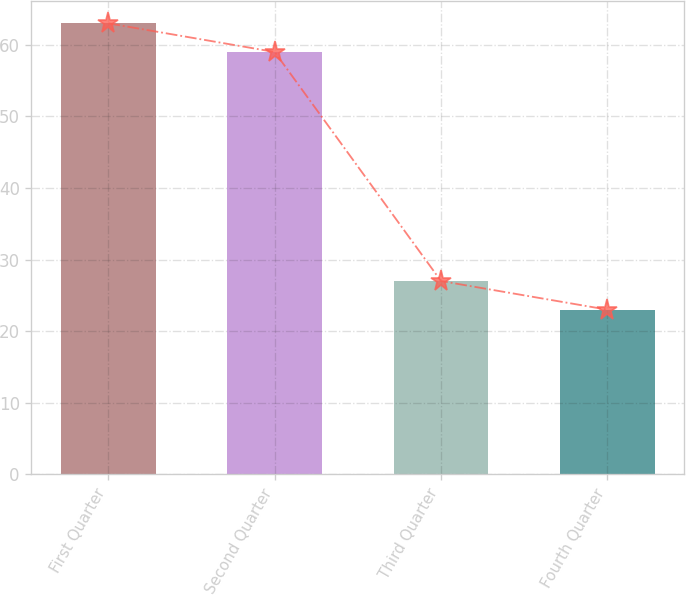Convert chart to OTSL. <chart><loc_0><loc_0><loc_500><loc_500><bar_chart><fcel>First Quarter<fcel>Second Quarter<fcel>Third Quarter<fcel>Fourth Quarter<nl><fcel>63<fcel>59<fcel>27<fcel>23<nl></chart> 